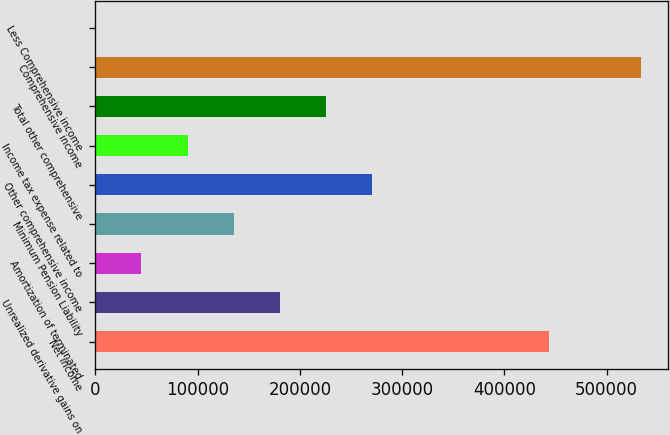<chart> <loc_0><loc_0><loc_500><loc_500><bar_chart><fcel>Net income<fcel>Unrealized derivative gains on<fcel>Amortization of terminated<fcel>Minimum Pension Liability<fcel>Other comprehensive income<fcel>Income tax expense related to<fcel>Total other comprehensive<fcel>Comprehensive income<fcel>Less Comprehensive income<nl><fcel>443446<fcel>180188<fcel>45047.9<fcel>135141<fcel>270281<fcel>90094.5<fcel>225234<fcel>533539<fcel>1.38<nl></chart> 